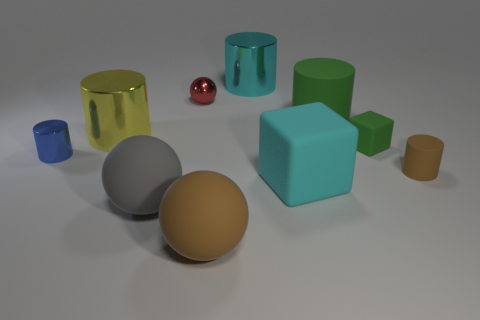Are there any objects that stand out due to their color? Yes, the small red sphere stands out because of its vibrant color, which contrasts with the other objects' more subdued hues. 